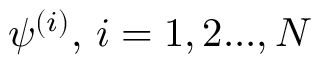Convert formula to latex. <formula><loc_0><loc_0><loc_500><loc_500>\psi ^ { ( i ) } , \, i = 1 , 2 \dots , N</formula> 